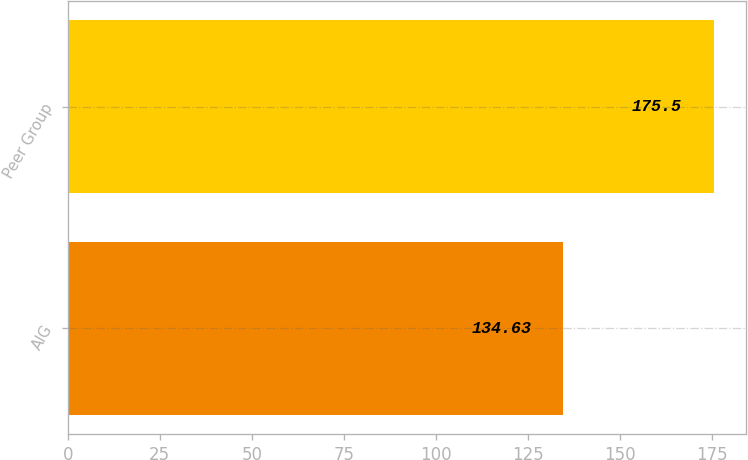<chart> <loc_0><loc_0><loc_500><loc_500><bar_chart><fcel>AIG<fcel>Peer Group<nl><fcel>134.63<fcel>175.5<nl></chart> 